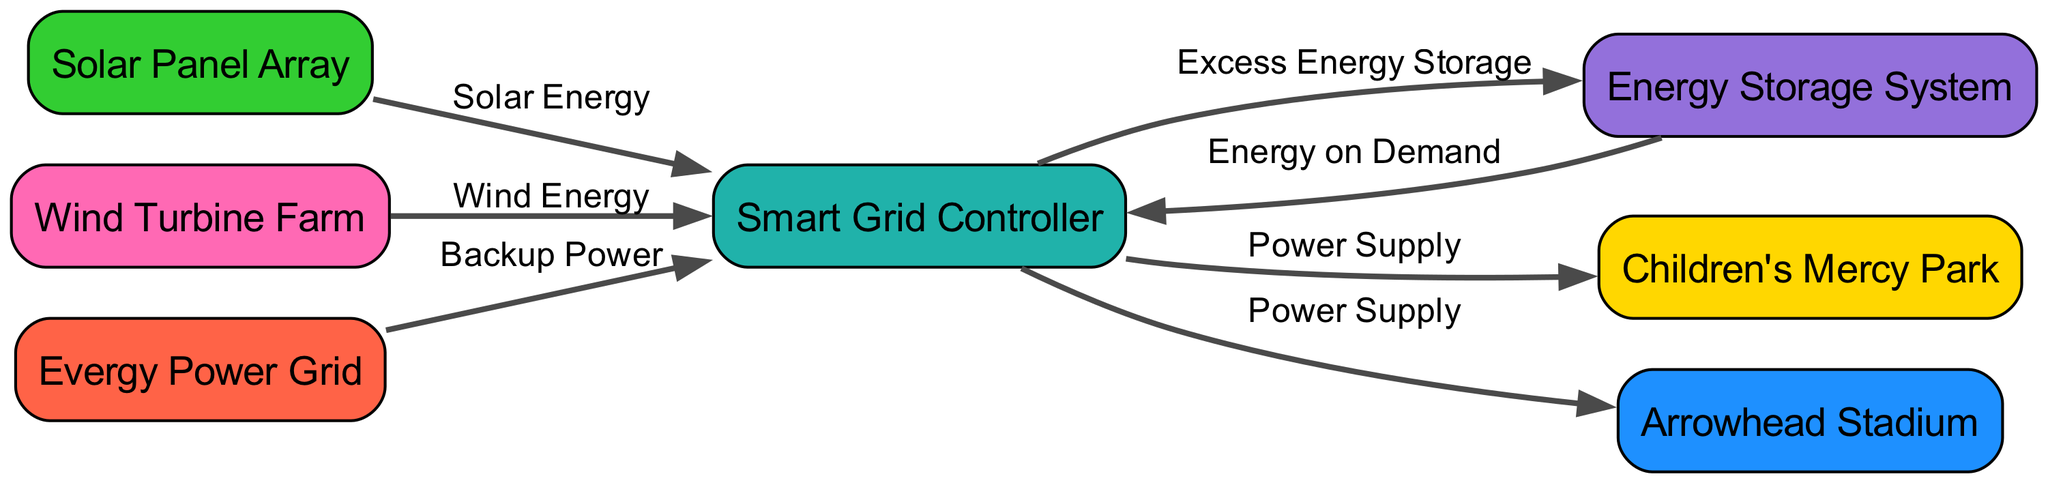What are the names of the two sports complexes powered by this diagram? The diagram shows two nodes representing sports complexes: Children's Mercy Park and Arrowhead Stadium. These nodes are directly connected to the Smart Grid Controller, indicating they receive power from it.
Answer: Children's Mercy Park, Arrowhead Stadium How many nodes are present in the diagram? The diagram contains a total of seven distinct nodes, including the two sports complexes, renewable energy sources, energy storage, smart grid controller, and the backup power grid.
Answer: Seven What type of energy is provided by the Solar Panel Array? The diagram specifies that the Solar Panel Array provides solar energy to the Smart Grid Controller, which is indicated by the edge labeled "Solar Energy."
Answer: Solar Energy What happens to excess energy produced by the renewable sources? According to the diagram, excess energy generated from the solar panels and wind turbines is stored in the Energy Storage System as indicated by the edges leading from the Smart Grid Controller to the Energy Storage System labeled "Excess Energy Storage."
Answer: Stored in Energy Storage System How does the Evergy Power Grid relate to the Smart Grid Controller? The Evergy Power Grid provides backup power to the Smart Grid Controller, as shown by the edge labeled "Backup Power" from Evergy Power Grid to the Smart Grid Controller.
Answer: Provides backup power What is the primary function of the Smart Grid Controller in the diagram? The Smart Grid Controller serves as the central point for managing power supply from renewable sources to the sports complexes and ensures energy is distributed effectively. The diagram shows multiple edges connecting it to both energy storage and the sports complexes, indicating its role in energy management.
Answer: Energy management Which node feeds energy on demand to the Smart Grid Controller? The diagram illustrates that the Energy Storage System sends energy on demand back to the Smart Grid Controller, as indicated by the edge labeled "Energy on Demand."
Answer: Energy Storage System How do the wind turbines contribute to the power supply? The Wind Turbine Farm contributes by sending wind energy to the Smart Grid Controller, which is indicated by the edge labeled "Wind Energy." This contribution helps power the sports complexes through the controller.
Answer: Wind Energy What is the relationship between the Smart Grid Controller and the two sports complexes? The relationship is defined by power supply; the Smart Grid Controller delivers power to both Children's Mercy Park and Arrowhead Stadium, as shown by the edges labeled "Power Supply."
Answer: Power Supply 